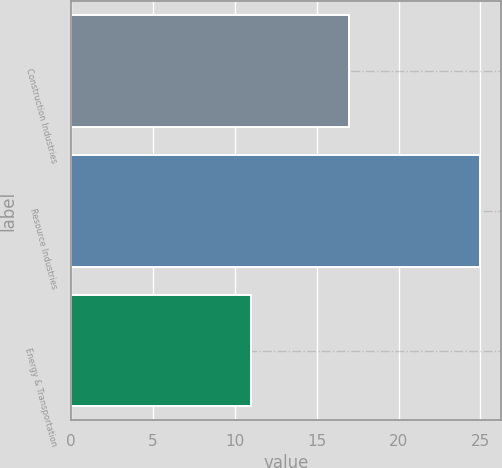<chart> <loc_0><loc_0><loc_500><loc_500><bar_chart><fcel>Construction Industries<fcel>Resource Industries<fcel>Energy & Transportation<nl><fcel>17<fcel>25<fcel>11<nl></chart> 